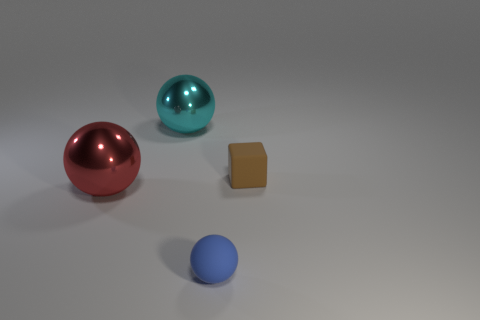There is a big ball that is to the left of the big object behind the small brown cube; what color is it?
Your answer should be very brief. Red. Do the tiny brown rubber object and the metallic thing that is to the left of the cyan metallic object have the same shape?
Give a very brief answer. No. What material is the small thing that is in front of the small rubber thing behind the small object in front of the red metal object made of?
Your answer should be compact. Rubber. Is there another rubber sphere that has the same size as the blue sphere?
Give a very brief answer. No. There is a sphere that is made of the same material as the cube; what size is it?
Provide a short and direct response. Small. What is the shape of the cyan metal thing?
Provide a short and direct response. Sphere. Does the big red thing have the same material as the small thing that is to the left of the small brown rubber object?
Give a very brief answer. No. How many things are big cyan objects or gray metallic things?
Ensure brevity in your answer.  1. Are there any brown rubber objects?
Offer a very short reply. Yes. What is the shape of the tiny thing behind the tiny matte object left of the tiny brown rubber thing?
Ensure brevity in your answer.  Cube. 